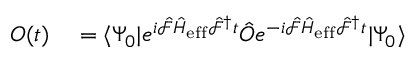<formula> <loc_0><loc_0><loc_500><loc_500>\begin{array} { r l } { O ( t ) } & = \langle \Psi _ { 0 } | e ^ { i \hat { \mathcal { F } } \hat { H } _ { e f f } \hat { \mathcal { F } } ^ { \dagger } t } \hat { O } e ^ { - i \hat { \mathcal { F } } \hat { H } _ { e f f } \hat { \mathcal { F } } ^ { \dagger } t } | \Psi _ { 0 } \rangle } \end{array}</formula> 